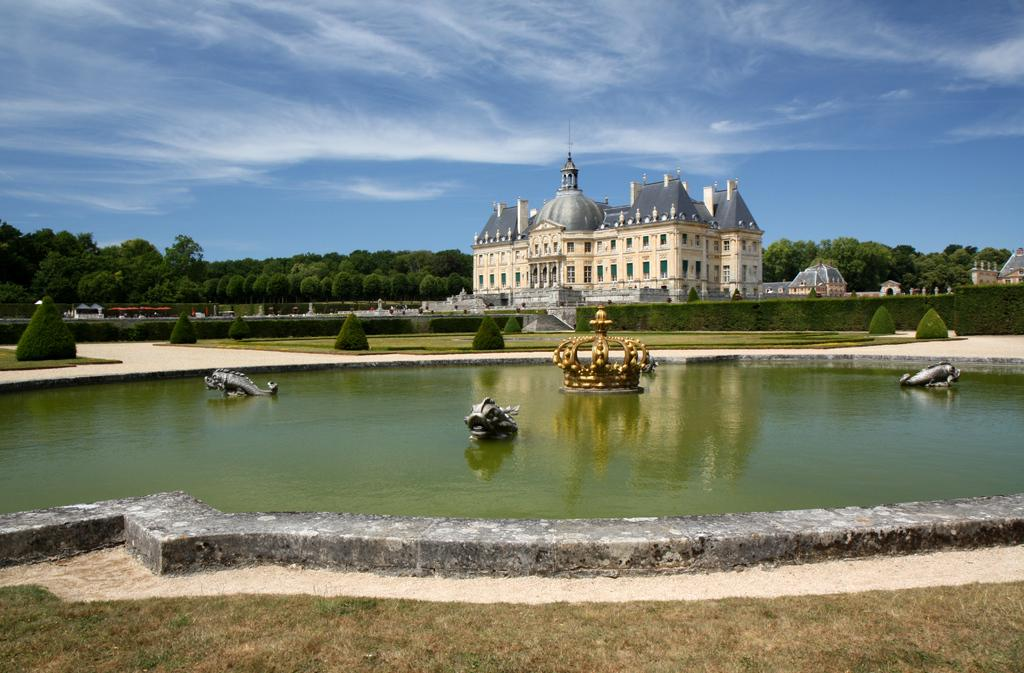What type of structures can be seen in the image? There are buildings in the image. What natural elements are present in the image? There are trees and plants in the image. What unique feature can be observed in the water? There are sculptures in the water in the image. What part of the natural environment is visible in the background? The sky is visible in the background of the image. What type of elbow can be seen in the image? There is no elbow present in the image. What kind of linen is draped over the sculptures in the water? There is no linen present in the image; the sculptures are in the water without any fabric covering them. 